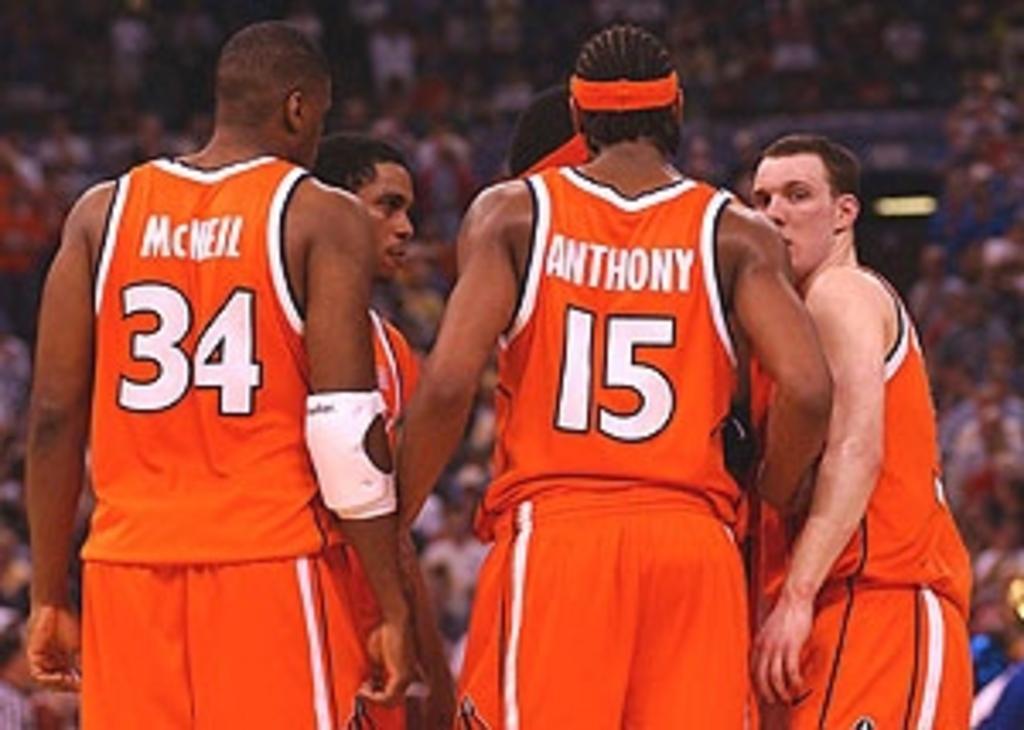Describe this image in one or two sentences. In this picture we can see a group of people standing on the ground and in the background we can see persons. 